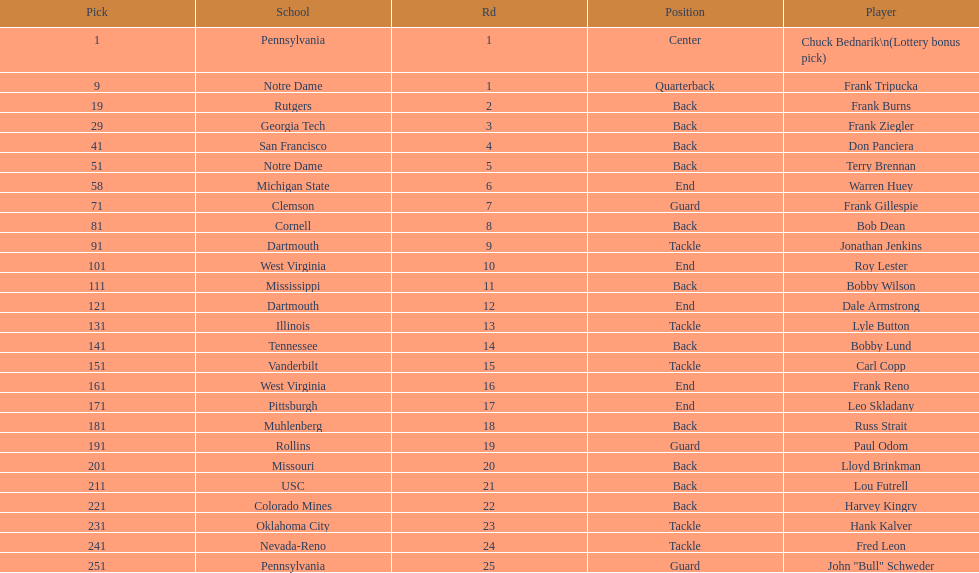What was the position that most of the players had? Back. 